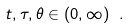<formula> <loc_0><loc_0><loc_500><loc_500>t , \tau , \theta \in ( 0 , \infty ) \ .</formula> 